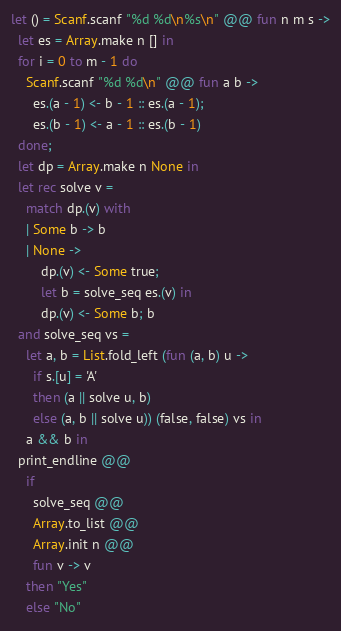<code> <loc_0><loc_0><loc_500><loc_500><_OCaml_>let () = Scanf.scanf "%d %d\n%s\n" @@ fun n m s ->
  let es = Array.make n [] in
  for i = 0 to m - 1 do
    Scanf.scanf "%d %d\n" @@ fun a b ->
      es.(a - 1) <- b - 1 :: es.(a - 1);
      es.(b - 1) <- a - 1 :: es.(b - 1)
  done;
  let dp = Array.make n None in
  let rec solve v =
    match dp.(v) with
    | Some b -> b
    | None ->
        dp.(v) <- Some true;
        let b = solve_seq es.(v) in
        dp.(v) <- Some b; b
  and solve_seq vs =
    let a, b = List.fold_left (fun (a, b) u ->
      if s.[u] = 'A'
      then (a || solve u, b)
      else (a, b || solve u)) (false, false) vs in
    a && b in
  print_endline @@
    if
      solve_seq @@
      Array.to_list @@
      Array.init n @@
      fun v -> v
    then "Yes"
    else "No"
</code> 